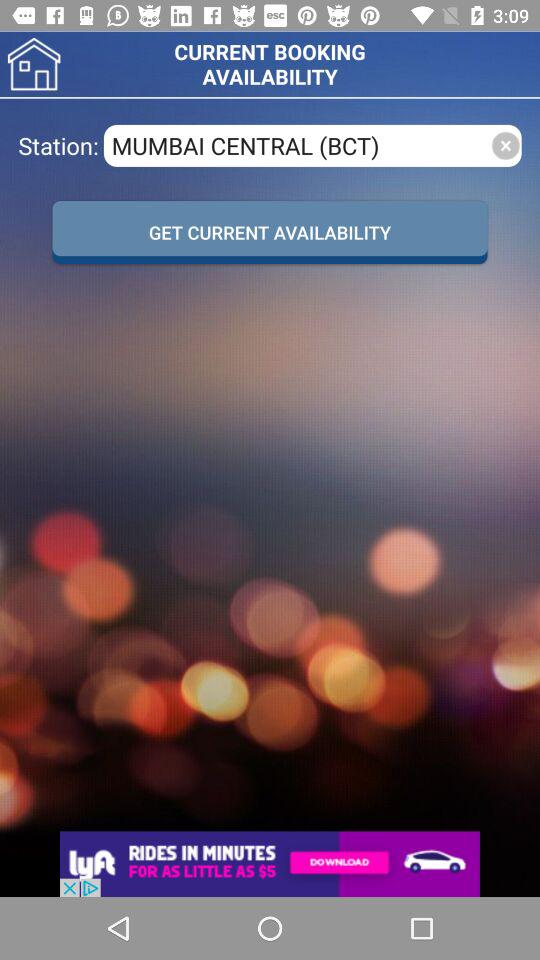What is the selected station? The selected station is "MUMBAI CENTRAL (BCT)". 